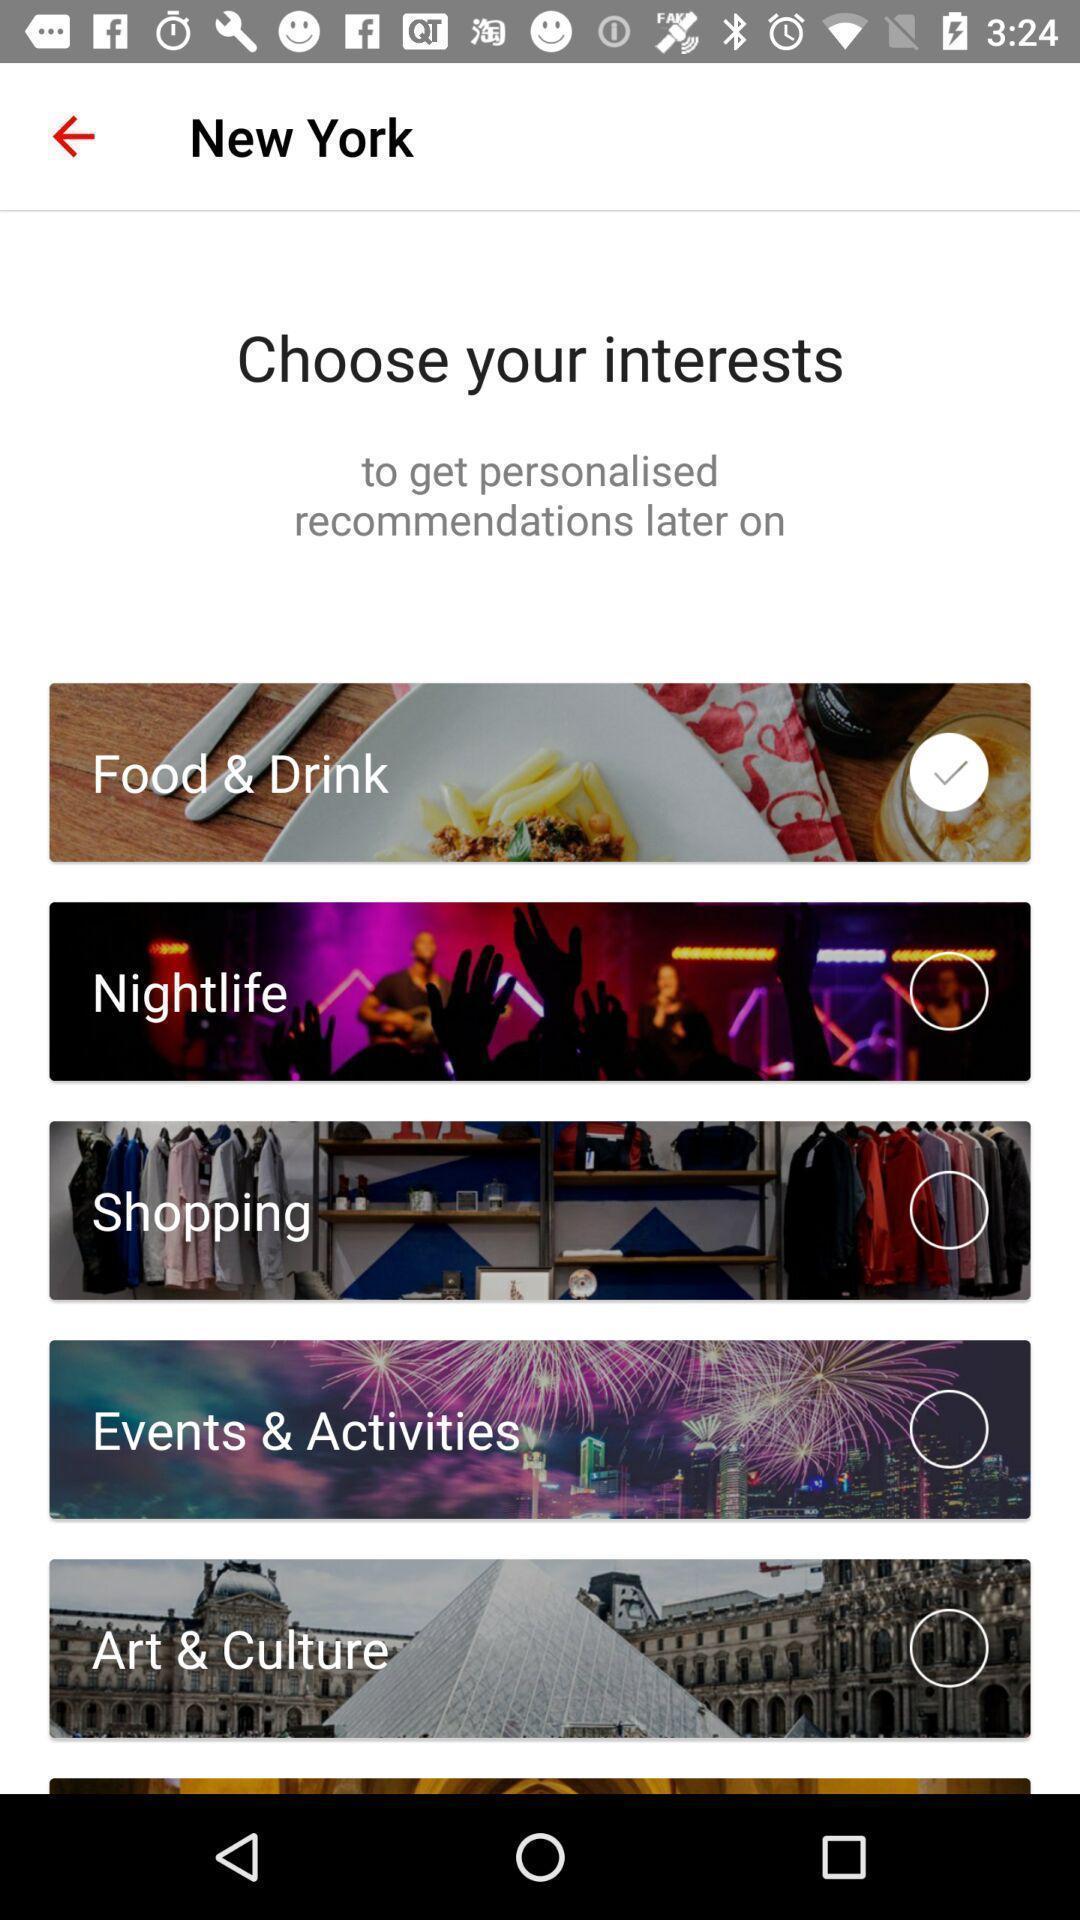Describe the content in this image. Screen displaying list of topics for choosing. 